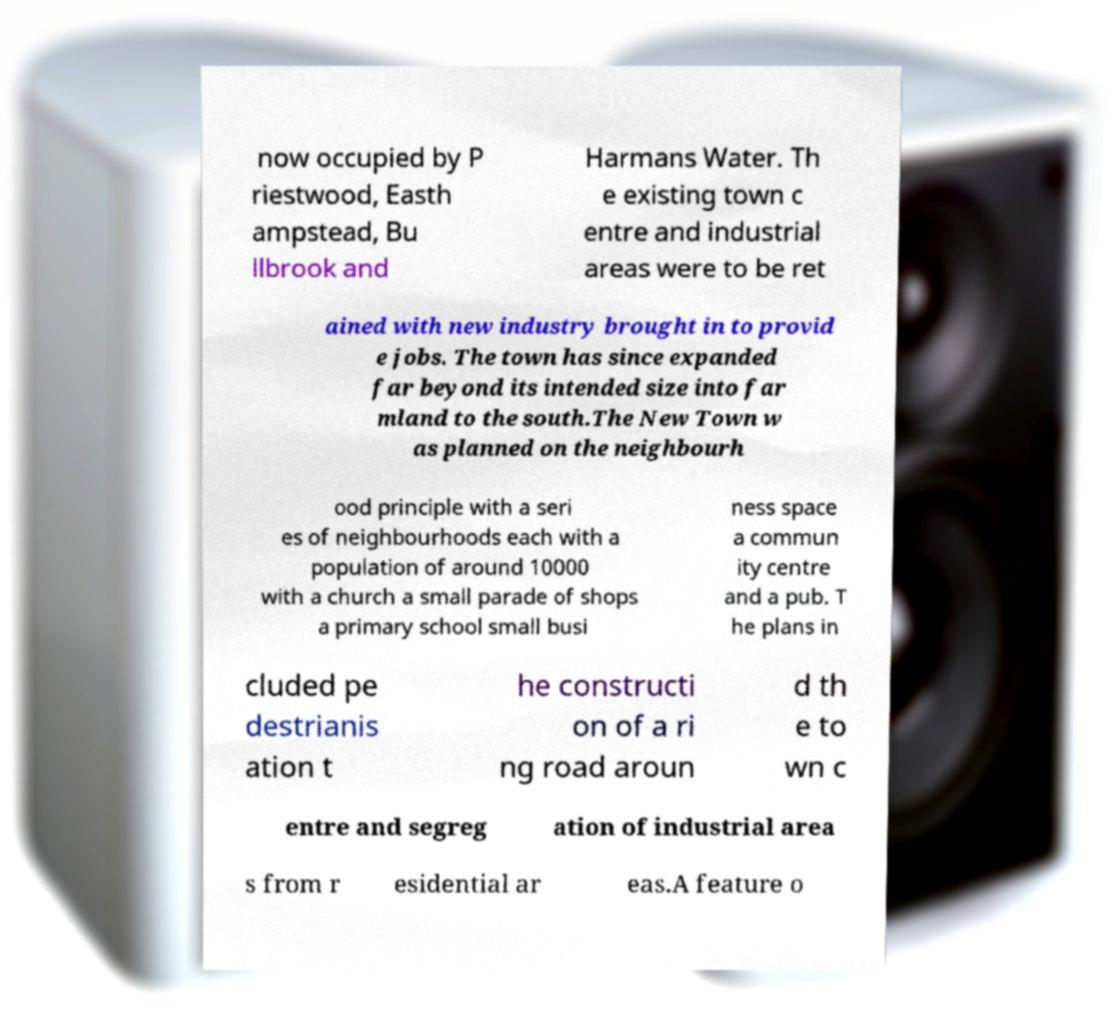Can you accurately transcribe the text from the provided image for me? now occupied by P riestwood, Easth ampstead, Bu llbrook and Harmans Water. Th e existing town c entre and industrial areas were to be ret ained with new industry brought in to provid e jobs. The town has since expanded far beyond its intended size into far mland to the south.The New Town w as planned on the neighbourh ood principle with a seri es of neighbourhoods each with a population of around 10000 with a church a small parade of shops a primary school small busi ness space a commun ity centre and a pub. T he plans in cluded pe destrianis ation t he constructi on of a ri ng road aroun d th e to wn c entre and segreg ation of industrial area s from r esidential ar eas.A feature o 